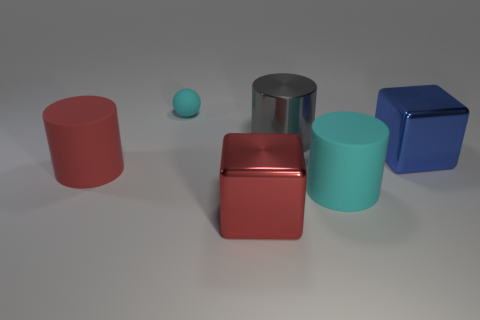Subtract all matte cylinders. How many cylinders are left? 1 Add 4 green rubber balls. How many objects exist? 10 Subtract all blue cylinders. Subtract all green cubes. How many cylinders are left? 3 Subtract all balls. How many objects are left? 5 Subtract 1 cyan spheres. How many objects are left? 5 Subtract all big cyan objects. Subtract all blue cubes. How many objects are left? 4 Add 1 small cyan rubber balls. How many small cyan rubber balls are left? 2 Add 2 red shiny things. How many red shiny things exist? 3 